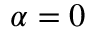<formula> <loc_0><loc_0><loc_500><loc_500>\alpha = 0</formula> 